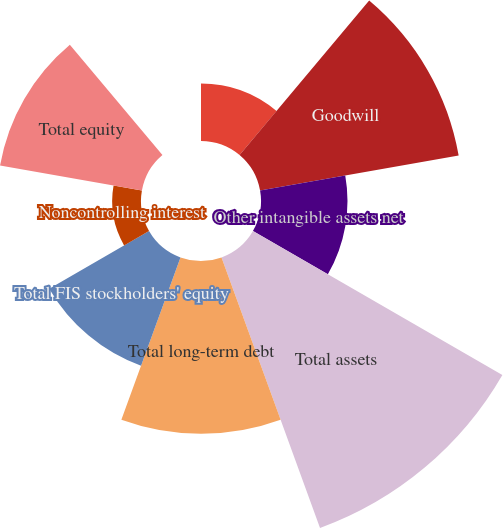Convert chart to OTSL. <chart><loc_0><loc_0><loc_500><loc_500><pie_chart><fcel>Cash and cash equivalents<fcel>Goodwill<fcel>Other intangible assets net<fcel>Total assets<fcel>Total long-term debt<fcel>Total FIS stockholders' equity<fcel>Noncontrolling interest<fcel>Total equity<fcel>Cash dividends declared per<nl><fcel>5.26%<fcel>18.42%<fcel>7.9%<fcel>26.31%<fcel>15.79%<fcel>10.53%<fcel>2.63%<fcel>13.16%<fcel>0.0%<nl></chart> 